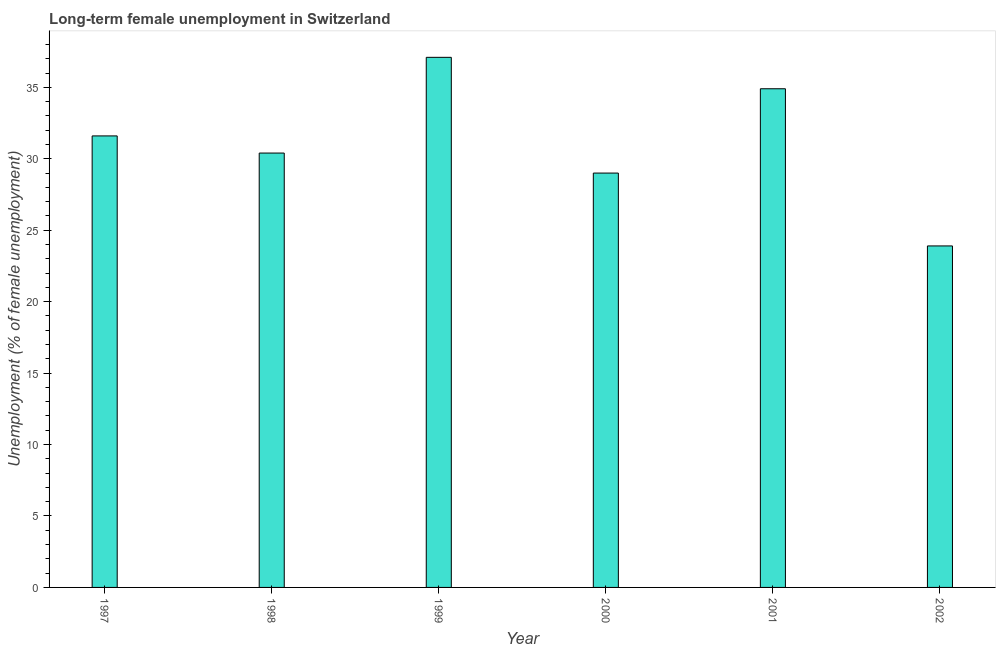What is the title of the graph?
Provide a succinct answer. Long-term female unemployment in Switzerland. What is the label or title of the Y-axis?
Your answer should be compact. Unemployment (% of female unemployment). What is the long-term female unemployment in 1998?
Provide a succinct answer. 30.4. Across all years, what is the maximum long-term female unemployment?
Give a very brief answer. 37.1. Across all years, what is the minimum long-term female unemployment?
Give a very brief answer. 23.9. In which year was the long-term female unemployment minimum?
Ensure brevity in your answer.  2002. What is the sum of the long-term female unemployment?
Your answer should be very brief. 186.9. What is the difference between the long-term female unemployment in 1997 and 1998?
Make the answer very short. 1.2. What is the average long-term female unemployment per year?
Provide a short and direct response. 31.15. What is the ratio of the long-term female unemployment in 2000 to that in 2001?
Provide a succinct answer. 0.83. What is the difference between the highest and the second highest long-term female unemployment?
Give a very brief answer. 2.2. Is the sum of the long-term female unemployment in 1997 and 2002 greater than the maximum long-term female unemployment across all years?
Your response must be concise. Yes. What is the difference between the highest and the lowest long-term female unemployment?
Offer a terse response. 13.2. How many years are there in the graph?
Give a very brief answer. 6. What is the Unemployment (% of female unemployment) in 1997?
Make the answer very short. 31.6. What is the Unemployment (% of female unemployment) in 1998?
Offer a very short reply. 30.4. What is the Unemployment (% of female unemployment) of 1999?
Your answer should be compact. 37.1. What is the Unemployment (% of female unemployment) in 2000?
Offer a very short reply. 29. What is the Unemployment (% of female unemployment) of 2001?
Provide a short and direct response. 34.9. What is the Unemployment (% of female unemployment) of 2002?
Give a very brief answer. 23.9. What is the difference between the Unemployment (% of female unemployment) in 1997 and 1998?
Your answer should be compact. 1.2. What is the difference between the Unemployment (% of female unemployment) in 1997 and 1999?
Make the answer very short. -5.5. What is the difference between the Unemployment (% of female unemployment) in 1998 and 2000?
Keep it short and to the point. 1.4. What is the difference between the Unemployment (% of female unemployment) in 1999 and 2001?
Offer a terse response. 2.2. What is the ratio of the Unemployment (% of female unemployment) in 1997 to that in 1998?
Your answer should be compact. 1.04. What is the ratio of the Unemployment (% of female unemployment) in 1997 to that in 1999?
Give a very brief answer. 0.85. What is the ratio of the Unemployment (% of female unemployment) in 1997 to that in 2000?
Provide a succinct answer. 1.09. What is the ratio of the Unemployment (% of female unemployment) in 1997 to that in 2001?
Offer a very short reply. 0.91. What is the ratio of the Unemployment (% of female unemployment) in 1997 to that in 2002?
Your answer should be very brief. 1.32. What is the ratio of the Unemployment (% of female unemployment) in 1998 to that in 1999?
Offer a very short reply. 0.82. What is the ratio of the Unemployment (% of female unemployment) in 1998 to that in 2000?
Your response must be concise. 1.05. What is the ratio of the Unemployment (% of female unemployment) in 1998 to that in 2001?
Offer a terse response. 0.87. What is the ratio of the Unemployment (% of female unemployment) in 1998 to that in 2002?
Provide a short and direct response. 1.27. What is the ratio of the Unemployment (% of female unemployment) in 1999 to that in 2000?
Your answer should be very brief. 1.28. What is the ratio of the Unemployment (% of female unemployment) in 1999 to that in 2001?
Offer a very short reply. 1.06. What is the ratio of the Unemployment (% of female unemployment) in 1999 to that in 2002?
Provide a succinct answer. 1.55. What is the ratio of the Unemployment (% of female unemployment) in 2000 to that in 2001?
Your answer should be very brief. 0.83. What is the ratio of the Unemployment (% of female unemployment) in 2000 to that in 2002?
Make the answer very short. 1.21. What is the ratio of the Unemployment (% of female unemployment) in 2001 to that in 2002?
Your response must be concise. 1.46. 